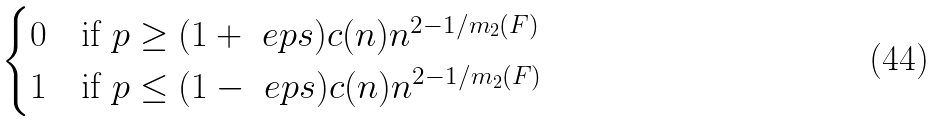<formula> <loc_0><loc_0><loc_500><loc_500>\begin{cases} 0 & \text {if } p \geq ( 1 + \ e p s ) c ( n ) n ^ { 2 - 1 / m _ { 2 } ( F ) } \\ 1 & \text {if } p \leq ( 1 - \ e p s ) c ( n ) n ^ { 2 - 1 / m _ { 2 } ( F ) } \\ \end{cases}</formula> 